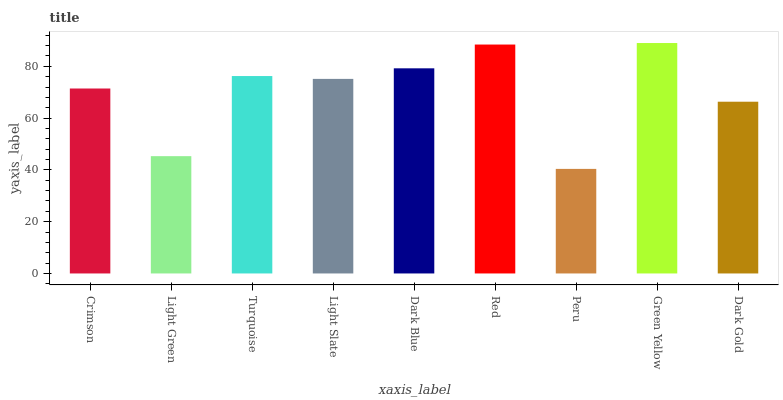Is Peru the minimum?
Answer yes or no. Yes. Is Green Yellow the maximum?
Answer yes or no. Yes. Is Light Green the minimum?
Answer yes or no. No. Is Light Green the maximum?
Answer yes or no. No. Is Crimson greater than Light Green?
Answer yes or no. Yes. Is Light Green less than Crimson?
Answer yes or no. Yes. Is Light Green greater than Crimson?
Answer yes or no. No. Is Crimson less than Light Green?
Answer yes or no. No. Is Light Slate the high median?
Answer yes or no. Yes. Is Light Slate the low median?
Answer yes or no. Yes. Is Dark Gold the high median?
Answer yes or no. No. Is Peru the low median?
Answer yes or no. No. 